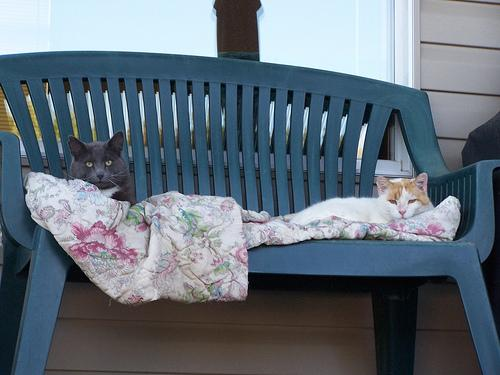What kind of prey do these animals hunt? mice 